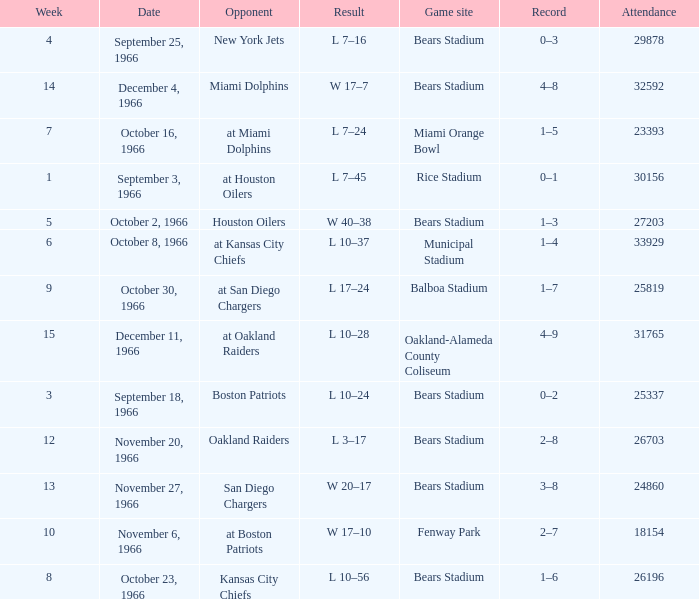Give me the full table as a dictionary. {'header': ['Week', 'Date', 'Opponent', 'Result', 'Game site', 'Record', 'Attendance'], 'rows': [['4', 'September 25, 1966', 'New York Jets', 'L 7–16', 'Bears Stadium', '0–3', '29878'], ['14', 'December 4, 1966', 'Miami Dolphins', 'W 17–7', 'Bears Stadium', '4–8', '32592'], ['7', 'October 16, 1966', 'at Miami Dolphins', 'L 7–24', 'Miami Orange Bowl', '1–5', '23393'], ['1', 'September 3, 1966', 'at Houston Oilers', 'L 7–45', 'Rice Stadium', '0–1', '30156'], ['5', 'October 2, 1966', 'Houston Oilers', 'W 40–38', 'Bears Stadium', '1–3', '27203'], ['6', 'October 8, 1966', 'at Kansas City Chiefs', 'L 10–37', 'Municipal Stadium', '1–4', '33929'], ['9', 'October 30, 1966', 'at San Diego Chargers', 'L 17–24', 'Balboa Stadium', '1–7', '25819'], ['15', 'December 11, 1966', 'at Oakland Raiders', 'L 10–28', 'Oakland-Alameda County Coliseum', '4–9', '31765'], ['3', 'September 18, 1966', 'Boston Patriots', 'L 10–24', 'Bears Stadium', '0–2', '25337'], ['12', 'November 20, 1966', 'Oakland Raiders', 'L 3–17', 'Bears Stadium', '2–8', '26703'], ['13', 'November 27, 1966', 'San Diego Chargers', 'W 20–17', 'Bears Stadium', '3–8', '24860'], ['10', 'November 6, 1966', 'at Boston Patriots', 'W 17–10', 'Fenway Park', '2–7', '18154'], ['8', 'October 23, 1966', 'Kansas City Chiefs', 'L 10–56', 'Bears Stadium', '1–6', '26196']]} How many results are listed for week 13? 1.0. 